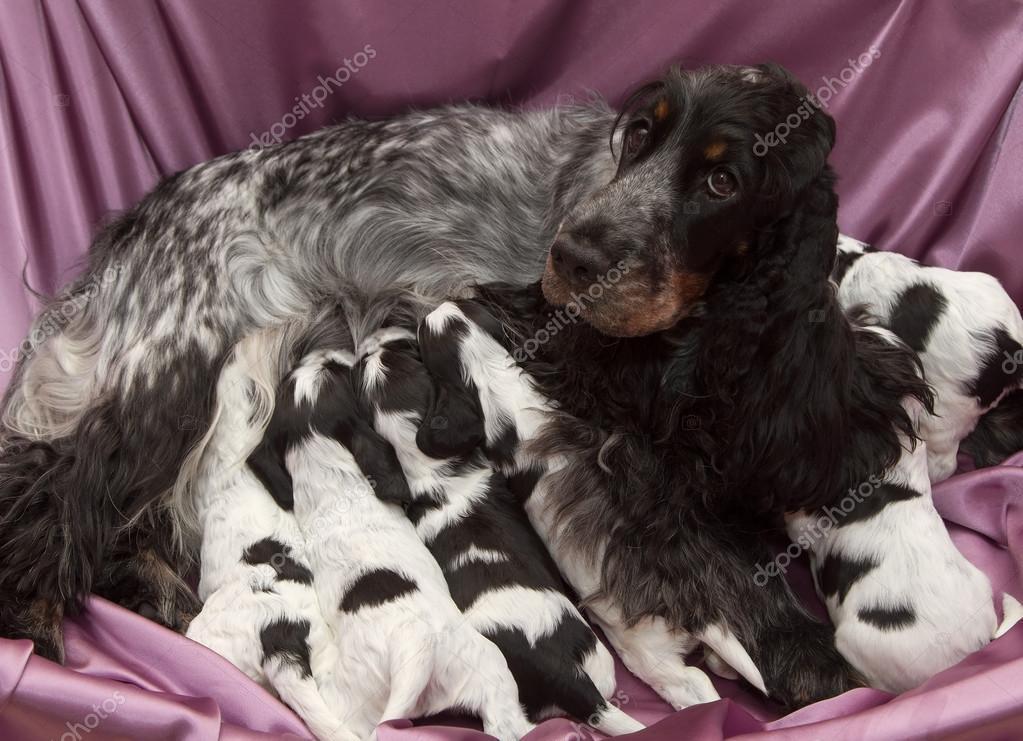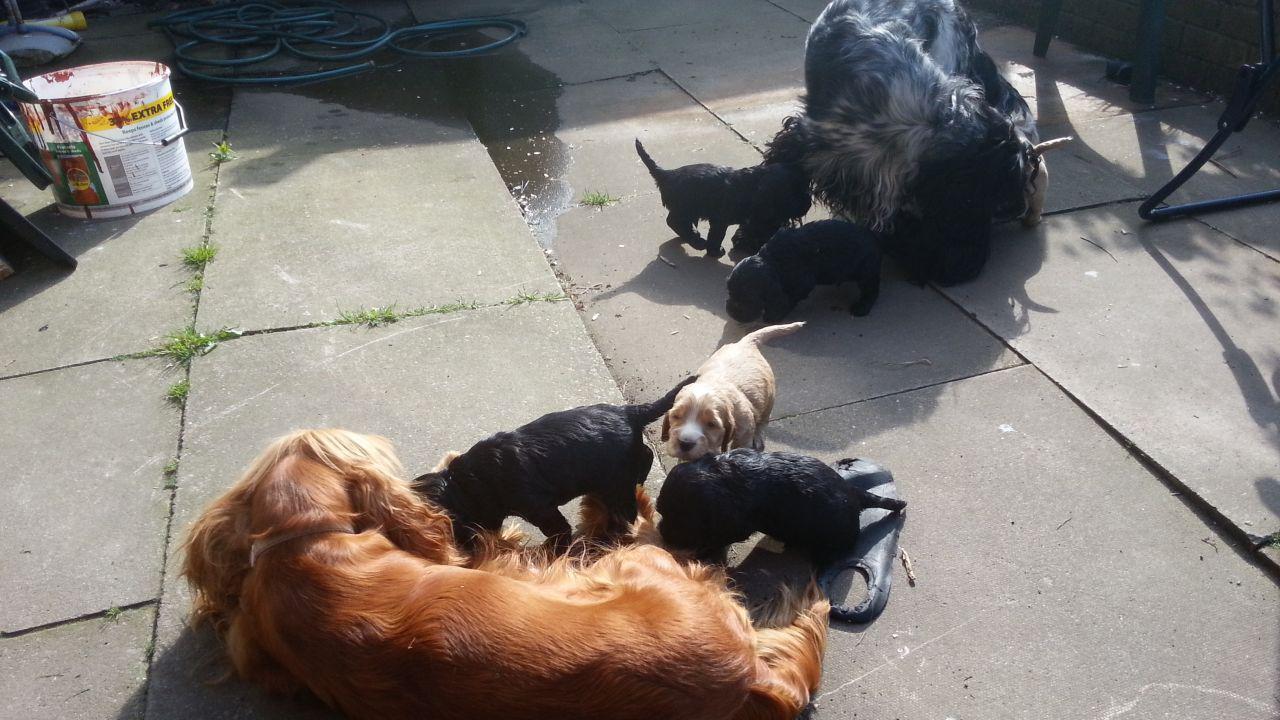The first image is the image on the left, the second image is the image on the right. Evaluate the accuracy of this statement regarding the images: "The right image contains no more than one dog.". Is it true? Answer yes or no. No. The first image is the image on the left, the second image is the image on the right. For the images shown, is this caption "A litter of puppies is being fed by their mother." true? Answer yes or no. Yes. 